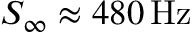Convert formula to latex. <formula><loc_0><loc_0><loc_500><loc_500>S _ { \infty } \approx 4 8 0 \, H z</formula> 